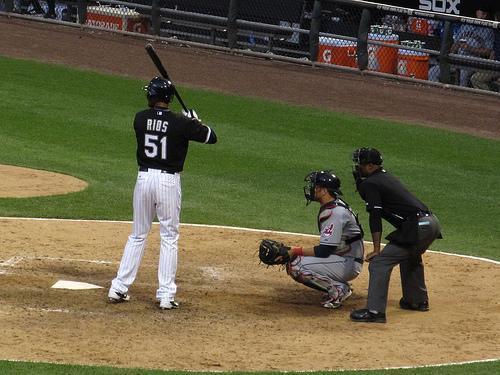How many men are on the field?
Give a very brief answer. 3. How many umpires are there?
Give a very brief answer. 1. 